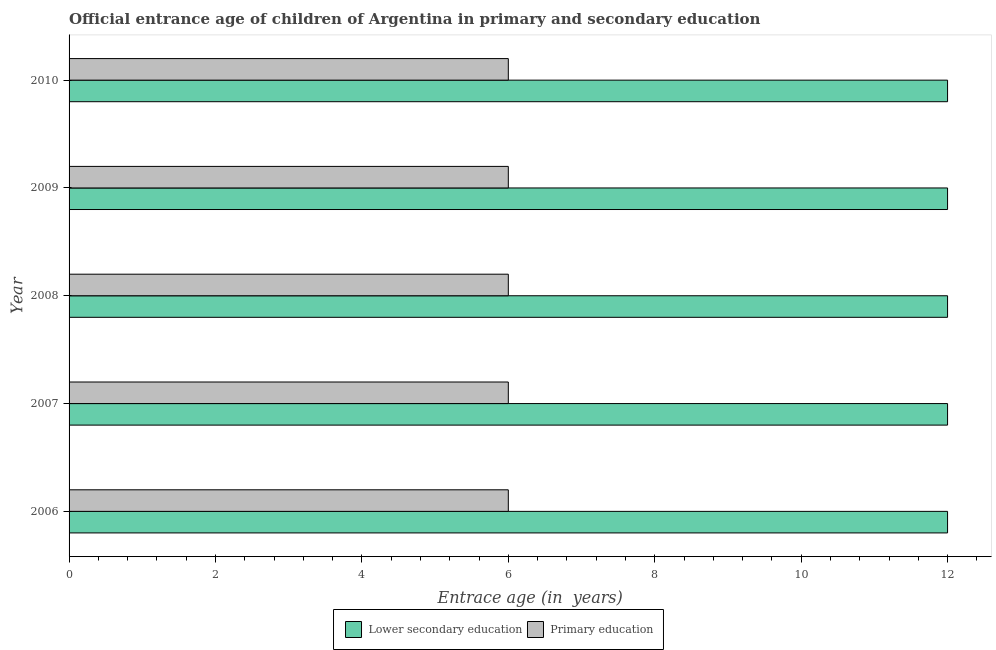How many groups of bars are there?
Offer a terse response. 5. Are the number of bars per tick equal to the number of legend labels?
Give a very brief answer. Yes. How many bars are there on the 5th tick from the top?
Keep it short and to the point. 2. In how many cases, is the number of bars for a given year not equal to the number of legend labels?
Provide a short and direct response. 0. What is the entrance age of chiildren in primary education in 2008?
Your response must be concise. 6. Across all years, what is the maximum entrance age of children in lower secondary education?
Give a very brief answer. 12. In which year was the entrance age of children in lower secondary education maximum?
Provide a succinct answer. 2006. In which year was the entrance age of chiildren in primary education minimum?
Provide a succinct answer. 2006. What is the total entrance age of children in lower secondary education in the graph?
Offer a very short reply. 60. What is the difference between the entrance age of chiildren in primary education in 2010 and the entrance age of children in lower secondary education in 2007?
Ensure brevity in your answer.  -6. In the year 2007, what is the difference between the entrance age of chiildren in primary education and entrance age of children in lower secondary education?
Make the answer very short. -6. In how many years, is the entrance age of chiildren in primary education greater than 1.6 years?
Your answer should be very brief. 5. What is the difference between the highest and the second highest entrance age of chiildren in primary education?
Make the answer very short. 0. Is the sum of the entrance age of chiildren in primary education in 2006 and 2008 greater than the maximum entrance age of children in lower secondary education across all years?
Make the answer very short. No. What does the 2nd bar from the top in 2007 represents?
Make the answer very short. Lower secondary education. How many bars are there?
Make the answer very short. 10. What is the difference between two consecutive major ticks on the X-axis?
Make the answer very short. 2. Does the graph contain grids?
Offer a very short reply. No. Where does the legend appear in the graph?
Provide a short and direct response. Bottom center. How many legend labels are there?
Offer a terse response. 2. How are the legend labels stacked?
Give a very brief answer. Horizontal. What is the title of the graph?
Your answer should be compact. Official entrance age of children of Argentina in primary and secondary education. Does "Attending school" appear as one of the legend labels in the graph?
Offer a very short reply. No. What is the label or title of the X-axis?
Offer a terse response. Entrace age (in  years). What is the label or title of the Y-axis?
Provide a succinct answer. Year. What is the Entrace age (in  years) of Lower secondary education in 2006?
Keep it short and to the point. 12. What is the Entrace age (in  years) of Lower secondary education in 2007?
Ensure brevity in your answer.  12. What is the Entrace age (in  years) of Primary education in 2007?
Provide a succinct answer. 6. What is the Entrace age (in  years) in Primary education in 2008?
Your answer should be very brief. 6. What is the Entrace age (in  years) in Lower secondary education in 2009?
Keep it short and to the point. 12. What is the Entrace age (in  years) of Primary education in 2010?
Offer a very short reply. 6. Across all years, what is the maximum Entrace age (in  years) of Lower secondary education?
Your answer should be compact. 12. What is the total Entrace age (in  years) in Lower secondary education in the graph?
Your response must be concise. 60. What is the difference between the Entrace age (in  years) of Lower secondary education in 2006 and that in 2007?
Your answer should be very brief. 0. What is the difference between the Entrace age (in  years) of Lower secondary education in 2006 and that in 2008?
Ensure brevity in your answer.  0. What is the difference between the Entrace age (in  years) in Primary education in 2006 and that in 2008?
Keep it short and to the point. 0. What is the difference between the Entrace age (in  years) of Primary education in 2006 and that in 2010?
Keep it short and to the point. 0. What is the difference between the Entrace age (in  years) in Lower secondary education in 2007 and that in 2008?
Give a very brief answer. 0. What is the difference between the Entrace age (in  years) of Primary education in 2008 and that in 2009?
Keep it short and to the point. 0. What is the difference between the Entrace age (in  years) of Lower secondary education in 2008 and that in 2010?
Ensure brevity in your answer.  0. What is the difference between the Entrace age (in  years) in Primary education in 2008 and that in 2010?
Your answer should be very brief. 0. What is the difference between the Entrace age (in  years) of Lower secondary education in 2009 and that in 2010?
Provide a succinct answer. 0. What is the difference between the Entrace age (in  years) of Primary education in 2009 and that in 2010?
Your response must be concise. 0. What is the difference between the Entrace age (in  years) in Lower secondary education in 2006 and the Entrace age (in  years) in Primary education in 2007?
Offer a very short reply. 6. What is the difference between the Entrace age (in  years) of Lower secondary education in 2007 and the Entrace age (in  years) of Primary education in 2008?
Offer a terse response. 6. What is the difference between the Entrace age (in  years) of Lower secondary education in 2008 and the Entrace age (in  years) of Primary education in 2009?
Your answer should be compact. 6. In the year 2006, what is the difference between the Entrace age (in  years) of Lower secondary education and Entrace age (in  years) of Primary education?
Your answer should be very brief. 6. In the year 2007, what is the difference between the Entrace age (in  years) in Lower secondary education and Entrace age (in  years) in Primary education?
Provide a short and direct response. 6. In the year 2009, what is the difference between the Entrace age (in  years) of Lower secondary education and Entrace age (in  years) of Primary education?
Provide a succinct answer. 6. What is the ratio of the Entrace age (in  years) of Lower secondary education in 2006 to that in 2007?
Offer a very short reply. 1. What is the ratio of the Entrace age (in  years) of Primary education in 2006 to that in 2007?
Ensure brevity in your answer.  1. What is the ratio of the Entrace age (in  years) of Lower secondary education in 2006 to that in 2009?
Make the answer very short. 1. What is the ratio of the Entrace age (in  years) of Lower secondary education in 2006 to that in 2010?
Your answer should be compact. 1. What is the ratio of the Entrace age (in  years) in Primary education in 2007 to that in 2008?
Offer a terse response. 1. What is the ratio of the Entrace age (in  years) of Lower secondary education in 2007 to that in 2009?
Provide a short and direct response. 1. What is the ratio of the Entrace age (in  years) in Primary education in 2007 to that in 2009?
Your answer should be very brief. 1. What is the ratio of the Entrace age (in  years) of Lower secondary education in 2008 to that in 2009?
Your answer should be compact. 1. What is the ratio of the Entrace age (in  years) in Lower secondary education in 2008 to that in 2010?
Provide a succinct answer. 1. What is the ratio of the Entrace age (in  years) in Lower secondary education in 2009 to that in 2010?
Your response must be concise. 1. What is the ratio of the Entrace age (in  years) of Primary education in 2009 to that in 2010?
Your answer should be compact. 1. What is the difference between the highest and the second highest Entrace age (in  years) in Lower secondary education?
Your answer should be very brief. 0. 